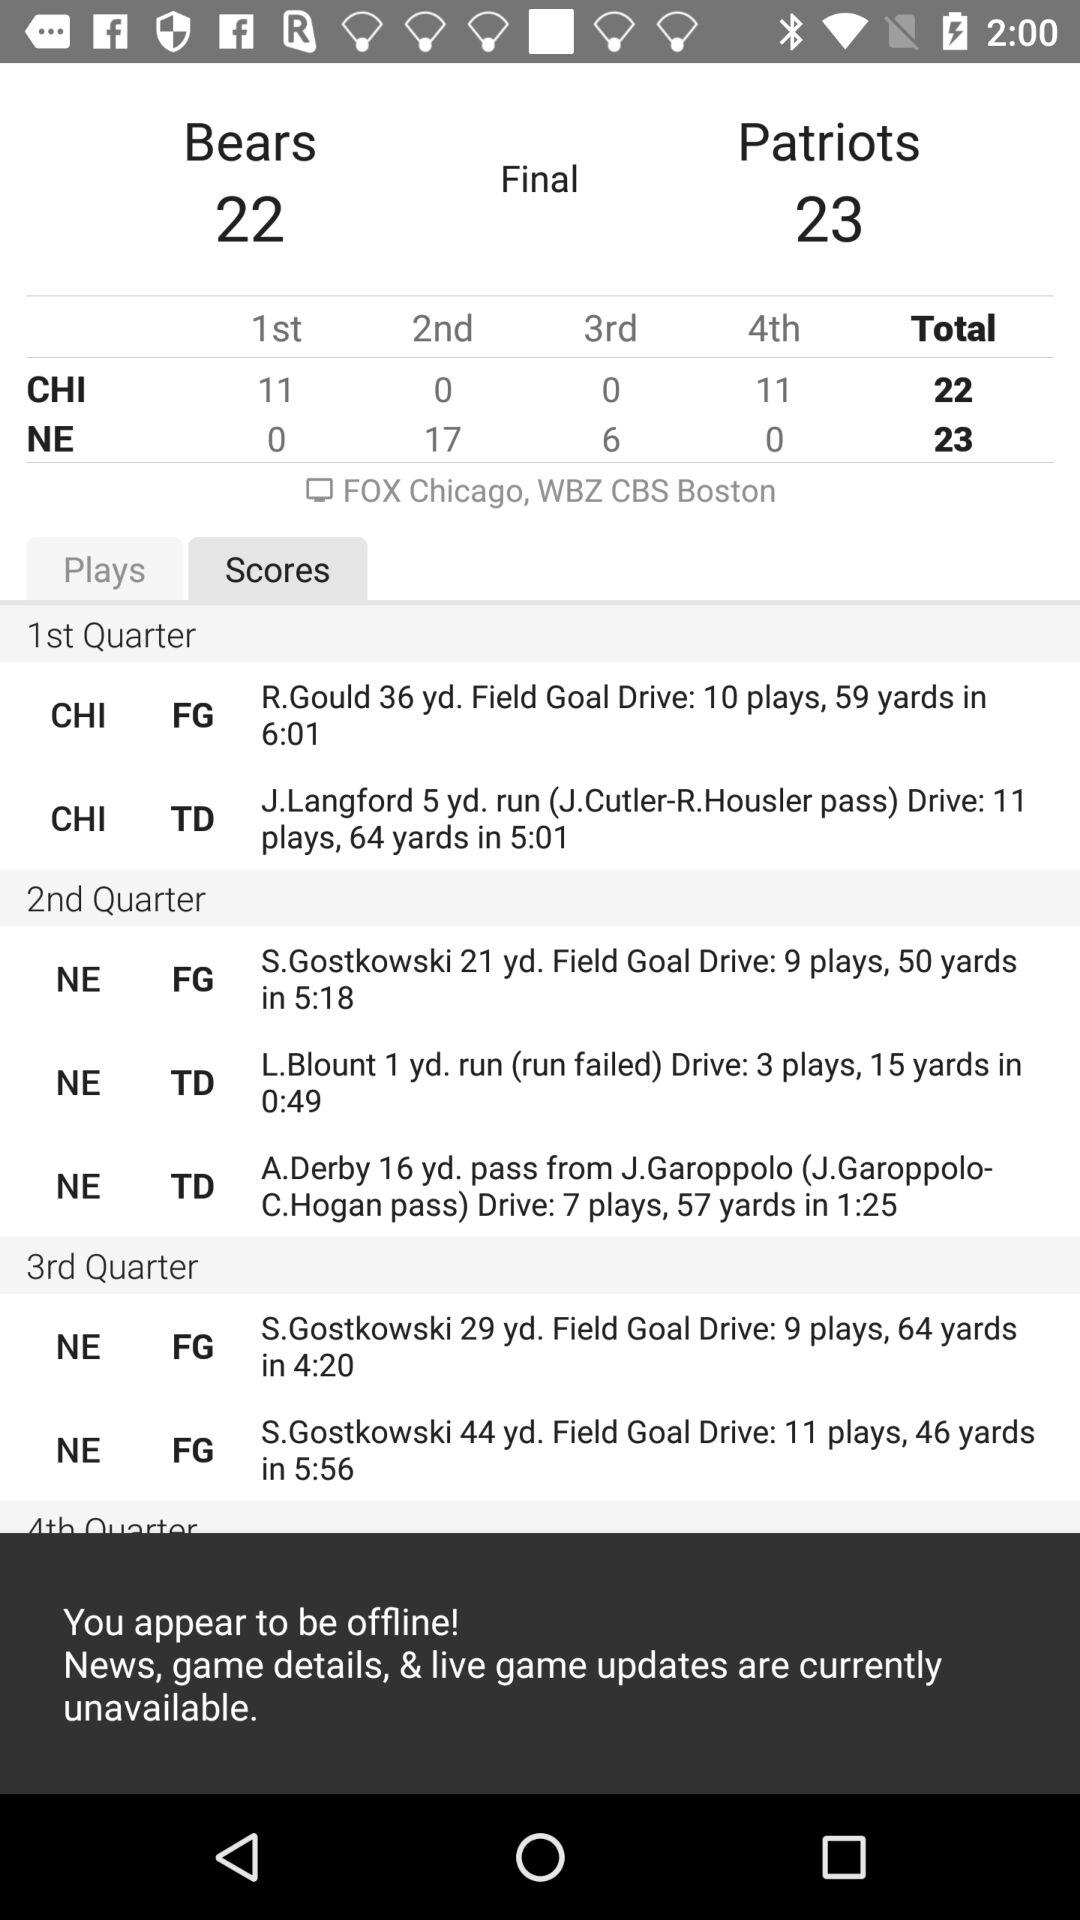What is the total score of CHI? The total score of CHI is 22. 